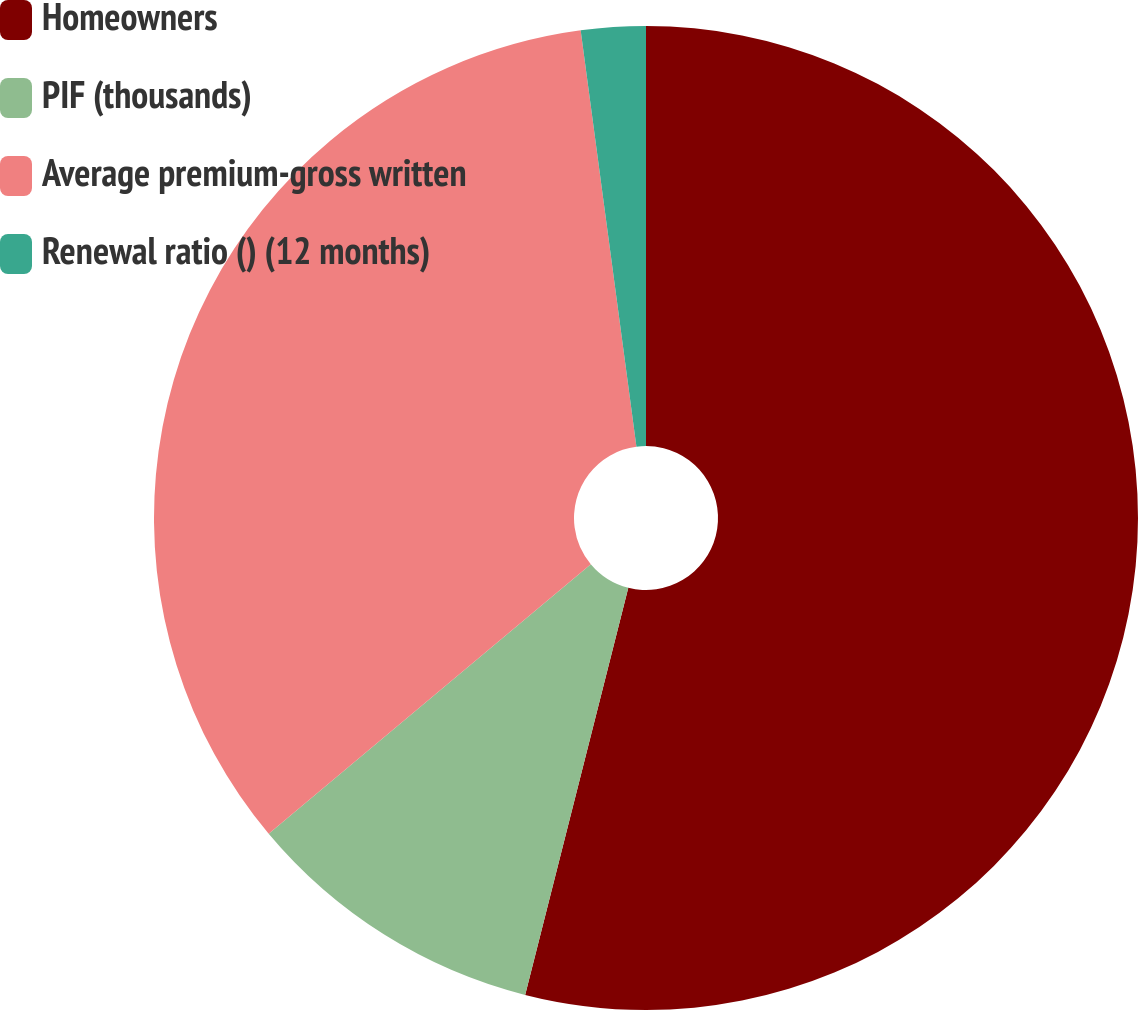Convert chart. <chart><loc_0><loc_0><loc_500><loc_500><pie_chart><fcel>Homeowners<fcel>PIF (thousands)<fcel>Average premium-gross written<fcel>Renewal ratio () (12 months)<nl><fcel>53.95%<fcel>9.96%<fcel>33.97%<fcel>2.12%<nl></chart> 